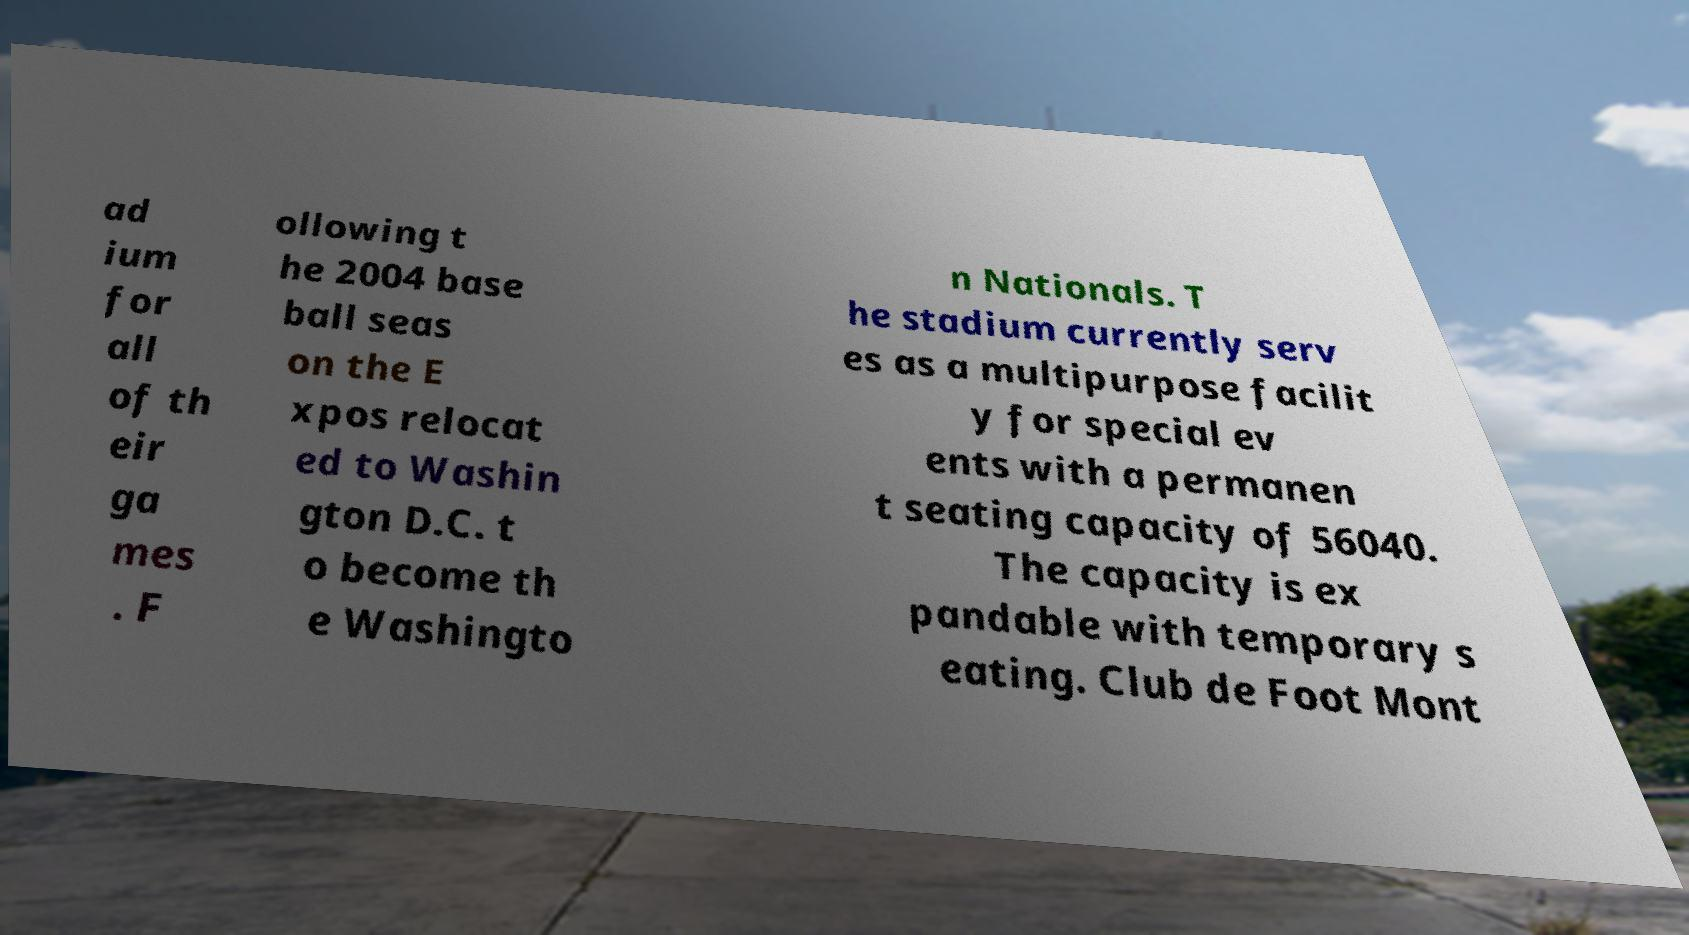Can you accurately transcribe the text from the provided image for me? ad ium for all of th eir ga mes . F ollowing t he 2004 base ball seas on the E xpos relocat ed to Washin gton D.C. t o become th e Washingto n Nationals. T he stadium currently serv es as a multipurpose facilit y for special ev ents with a permanen t seating capacity of 56040. The capacity is ex pandable with temporary s eating. Club de Foot Mont 